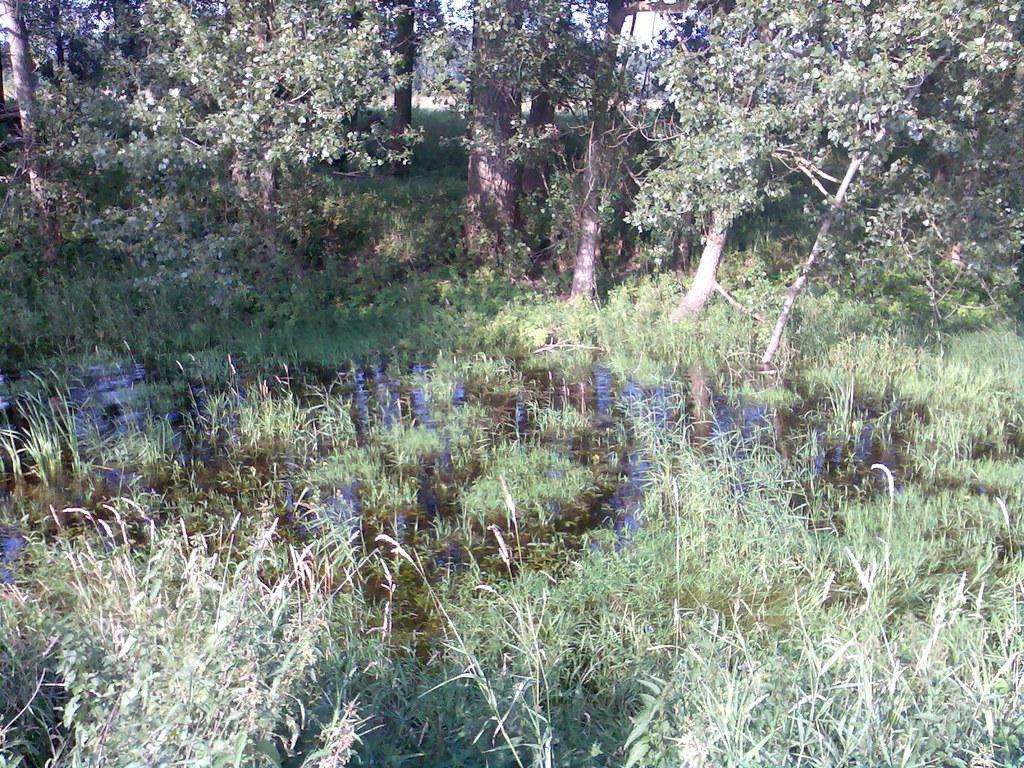How would you summarize this image in a sentence or two? In this image we can see trees, plants and water. 